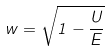Convert formula to latex. <formula><loc_0><loc_0><loc_500><loc_500>w = \sqrt { 1 - \frac { U } { E } }</formula> 